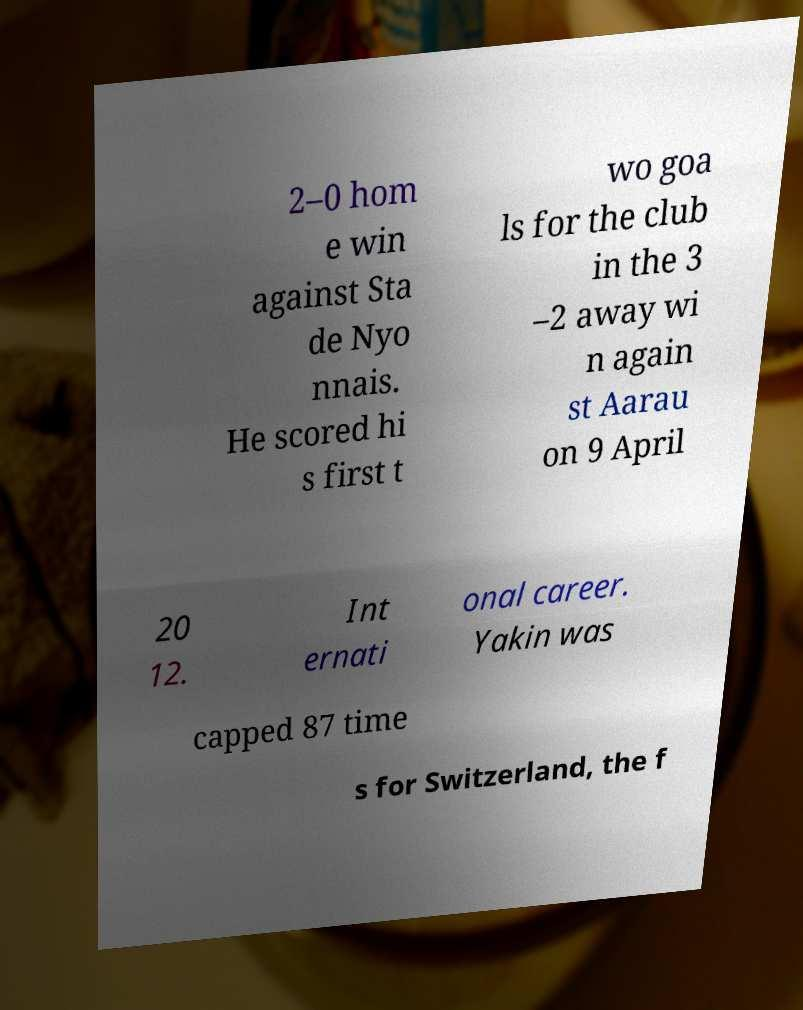For documentation purposes, I need the text within this image transcribed. Could you provide that? 2–0 hom e win against Sta de Nyo nnais. He scored hi s first t wo goa ls for the club in the 3 –2 away wi n again st Aarau on 9 April 20 12. Int ernati onal career. Yakin was capped 87 time s for Switzerland, the f 